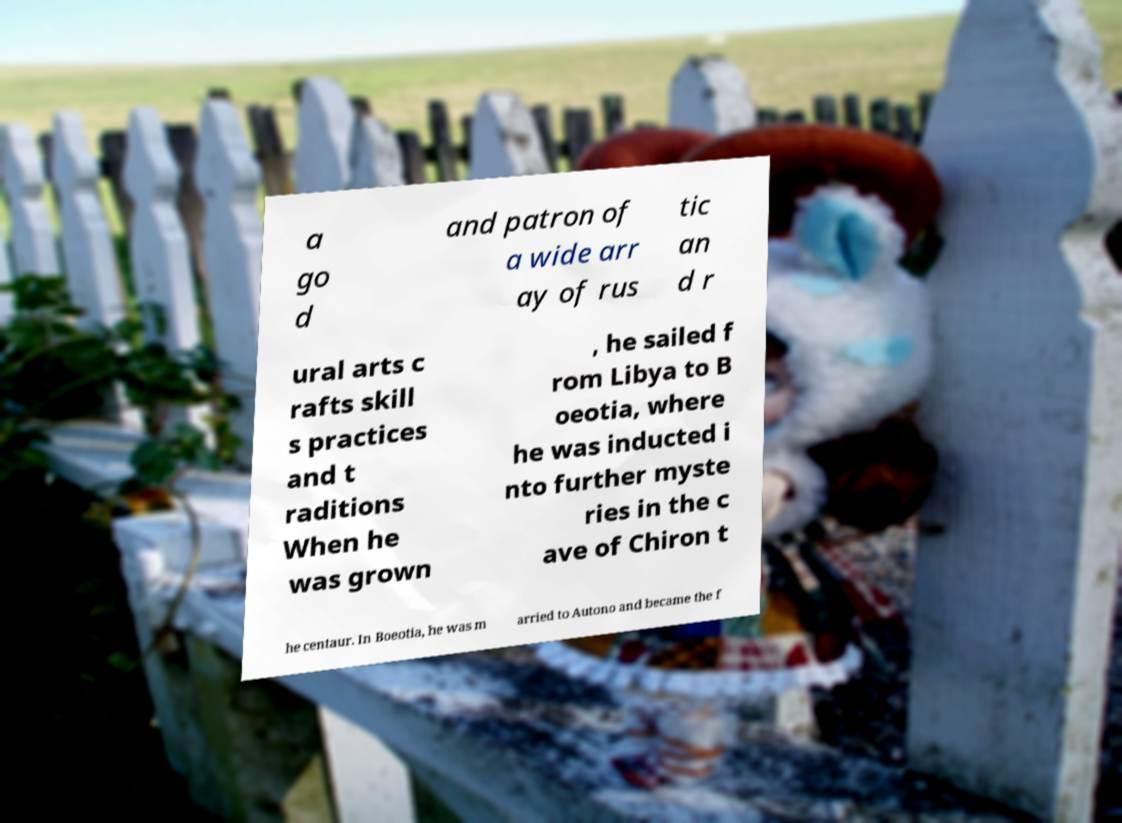Please identify and transcribe the text found in this image. a go d and patron of a wide arr ay of rus tic an d r ural arts c rafts skill s practices and t raditions When he was grown , he sailed f rom Libya to B oeotia, where he was inducted i nto further myste ries in the c ave of Chiron t he centaur. In Boeotia, he was m arried to Autono and became the f 